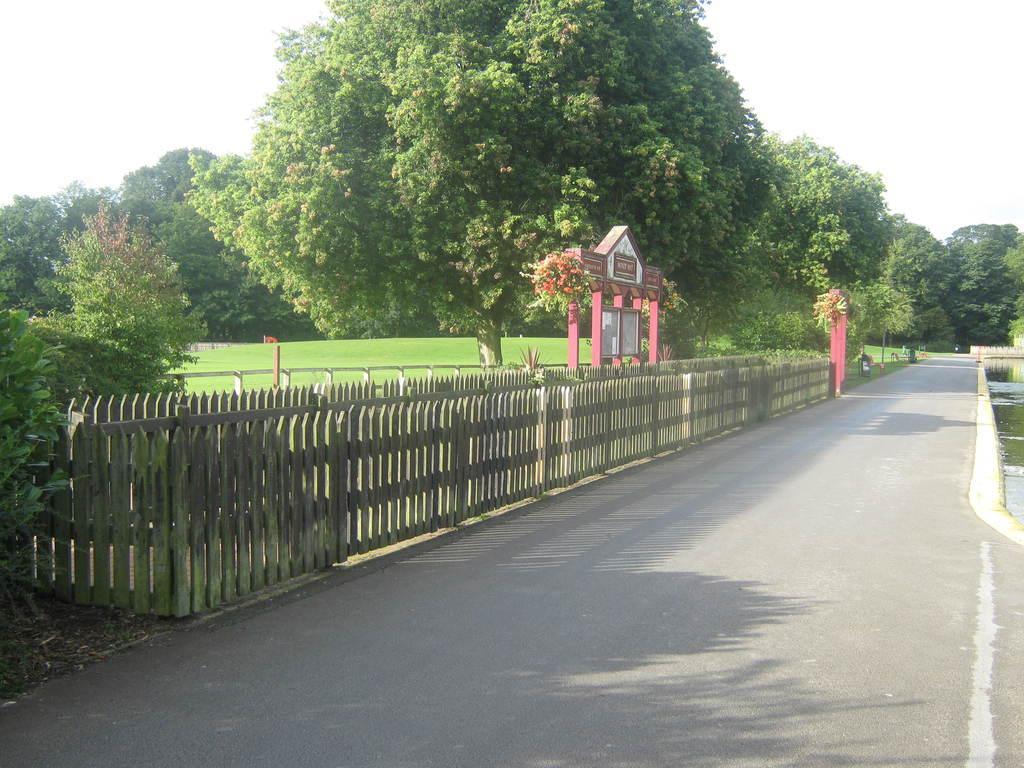How would you summarize this image in a sentence or two? In this image there is a road in the background there is fencing, trees and the sky. 